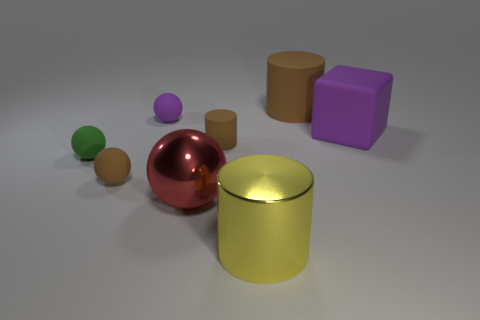Does the big cylinder that is behind the big metal ball have the same color as the tiny rubber cylinder?
Provide a short and direct response. Yes. The other matte cylinder that is the same color as the tiny cylinder is what size?
Your response must be concise. Large. Do the tiny matte cylinder and the large rubber cylinder have the same color?
Ensure brevity in your answer.  Yes. Is there a tiny sphere that has the same color as the cube?
Your answer should be compact. Yes. What color is the small cylinder that is the same material as the big purple cube?
Your response must be concise. Brown. There is a large rubber cylinder; is it the same color as the matte cylinder on the left side of the large yellow metal cylinder?
Provide a short and direct response. Yes. What color is the thing that is both left of the yellow shiny thing and on the right side of the big red ball?
Provide a short and direct response. Brown. There is a big red metal sphere; what number of objects are in front of it?
Keep it short and to the point. 1. How many things are large purple metallic spheres or brown things that are behind the purple sphere?
Your response must be concise. 1. There is a tiny brown matte object in front of the tiny green ball; is there a green object right of it?
Your answer should be very brief. No. 